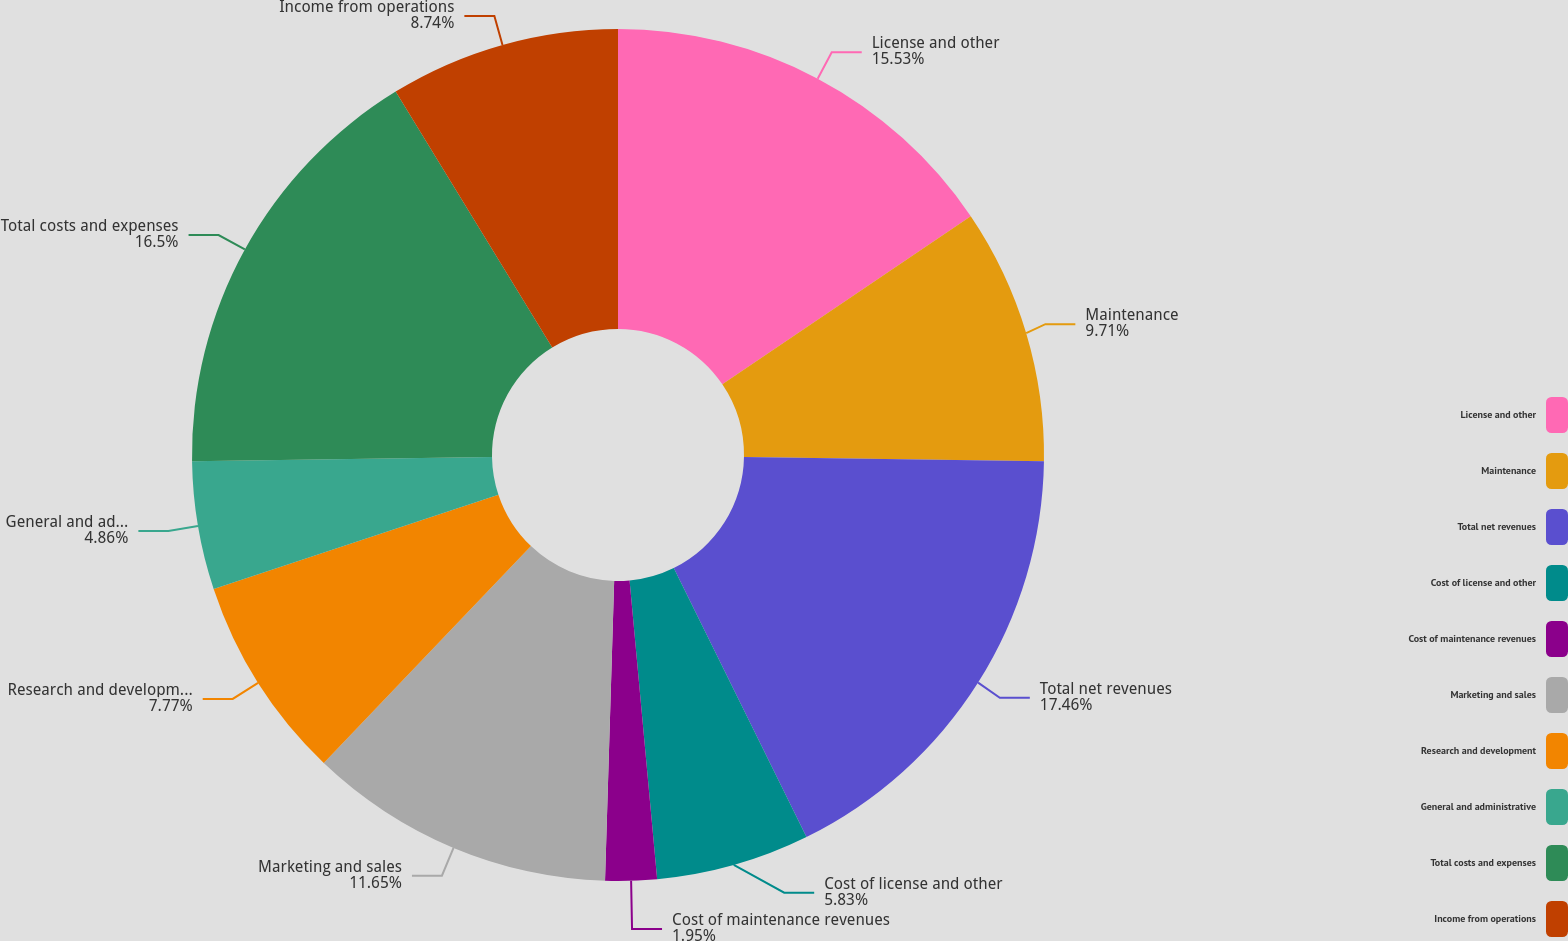Convert chart to OTSL. <chart><loc_0><loc_0><loc_500><loc_500><pie_chart><fcel>License and other<fcel>Maintenance<fcel>Total net revenues<fcel>Cost of license and other<fcel>Cost of maintenance revenues<fcel>Marketing and sales<fcel>Research and development<fcel>General and administrative<fcel>Total costs and expenses<fcel>Income from operations<nl><fcel>15.53%<fcel>9.71%<fcel>17.47%<fcel>5.83%<fcel>1.95%<fcel>11.65%<fcel>7.77%<fcel>4.86%<fcel>16.5%<fcel>8.74%<nl></chart> 